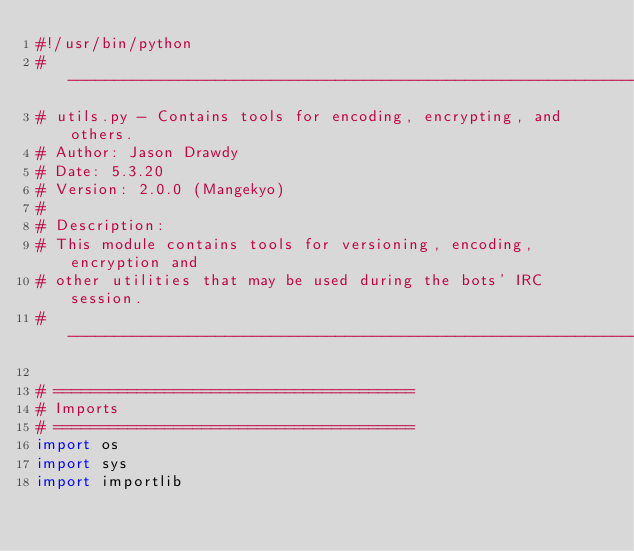Convert code to text. <code><loc_0><loc_0><loc_500><loc_500><_Python_>#!/usr/bin/python
# -------------------------------------------------------------------------
# utils.py - Contains tools for encoding, encrypting, and others.
# Author: Jason Drawdy
# Date: 5.3.20
# Version: 2.0.0 (Mangekyo)
#
# Description:
# This module contains tools for versioning, encoding, encryption and
# other utilities that may be used during the bots' IRC session.
# -------------------------------------------------------------------------

# =======================================
# Imports
# =======================================
import os
import sys
import importlib</code> 